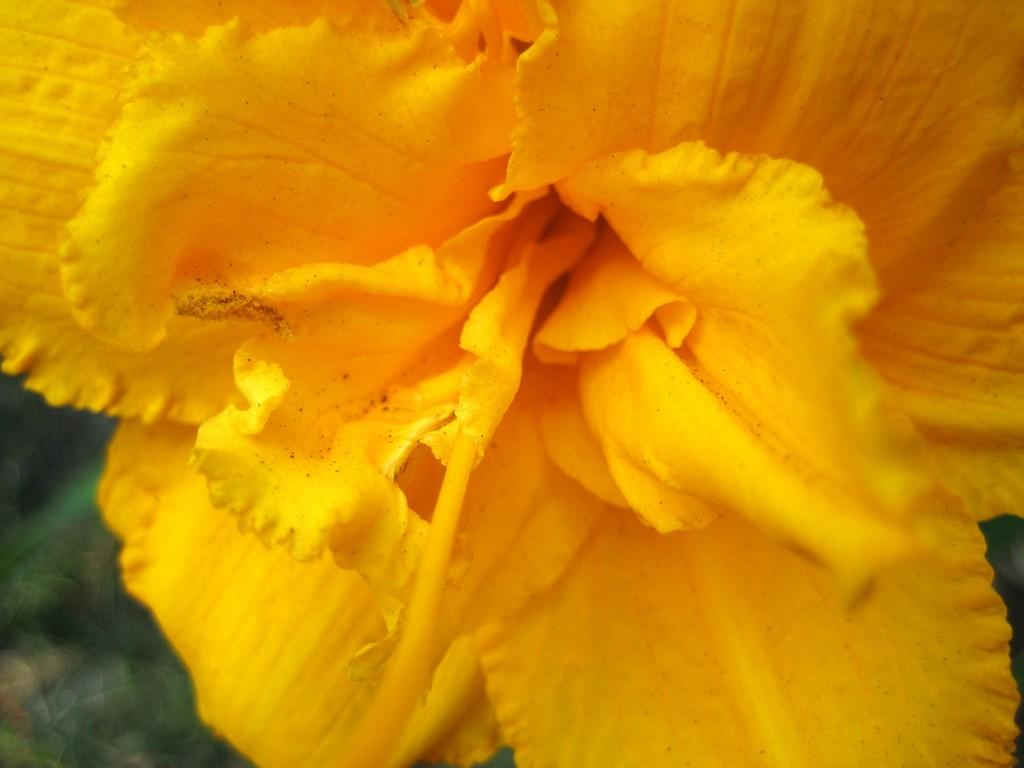What type of flower is present in the image? There is a yellow flower in the image. What type of building is depicted in the image? There is no building present in the image; it only features a yellow flower. What thought or emotion is expressed by the flower in the image? Flowers do not express thoughts or emotions, as they are inanimate objects. 